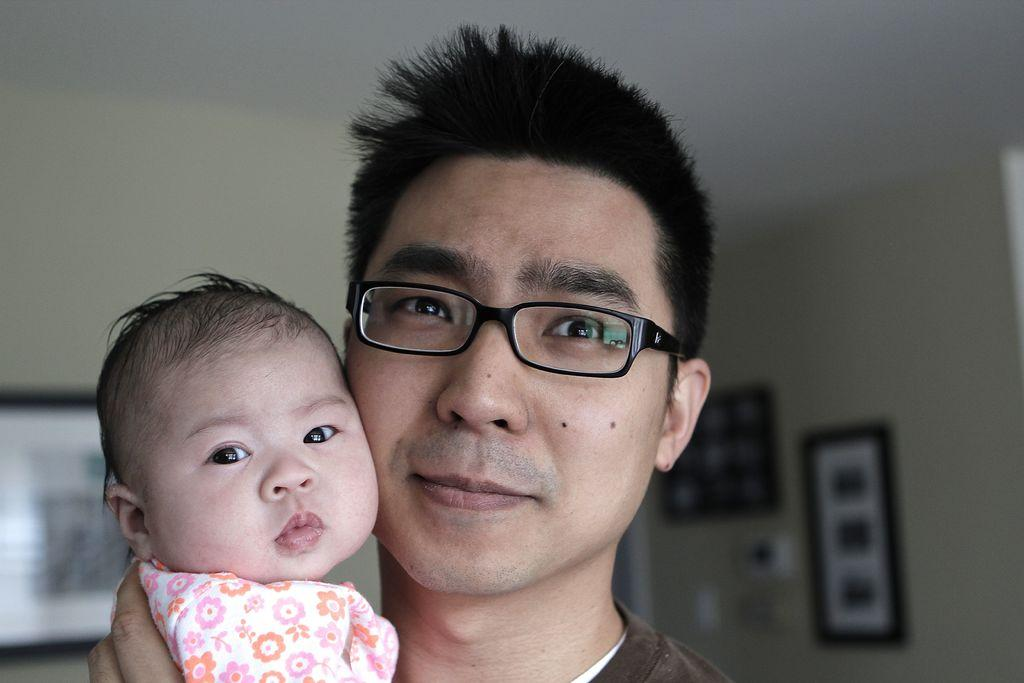Who is the main subject in the foreground of the image? There is a man in the foreground of the image. What is the man doing in the image? The man is holding a baby. What can be seen in the background of the image? There is a wall in the background of the image. What is on the wall in the image? There are photo frames on the wall. Can you see any elbows in the image? There is no mention of elbows in the provided facts, so it cannot be determined if any elbows are visible in the image. Is there a board visible in the image? There is no mention of a board in the provided facts, so it cannot be determined if a board is visible in the image. 